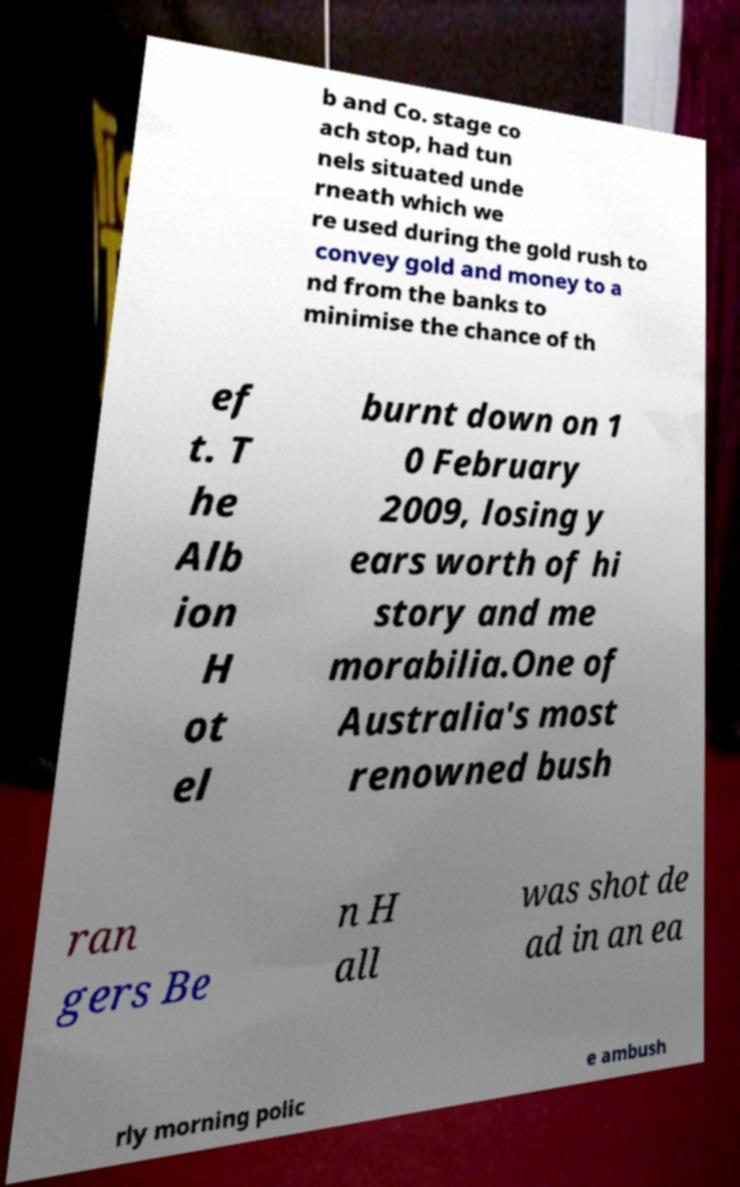For documentation purposes, I need the text within this image transcribed. Could you provide that? b and Co. stage co ach stop, had tun nels situated unde rneath which we re used during the gold rush to convey gold and money to a nd from the banks to minimise the chance of th ef t. T he Alb ion H ot el burnt down on 1 0 February 2009, losing y ears worth of hi story and me morabilia.One of Australia's most renowned bush ran gers Be n H all was shot de ad in an ea rly morning polic e ambush 